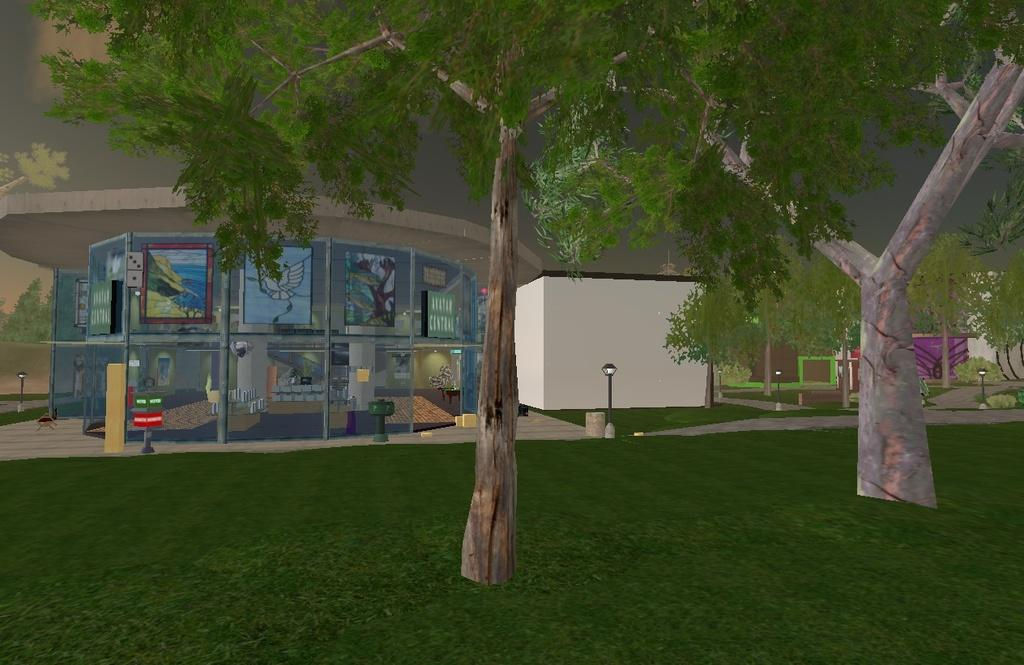What type of art is featured in the image? The image contains digital art. What natural elements are depicted in the digital art? There is grass and trees depicted in the digital art. What man-made structures are depicted in the digital art? There are buildings depicted in the digital art. What color are the poles depicted in the digital art? The poles are black colored. What is visible in the background of the digital art? The sky is visible in the background of the digital art. Can you tell me how many kitties are playing near the river in the image? There is no river or kitties present in the image; it features digital art with grass, trees, buildings, and black poles. What type of porter is carrying the luggage in the image? There is no luggage or porter depicted in the image. 